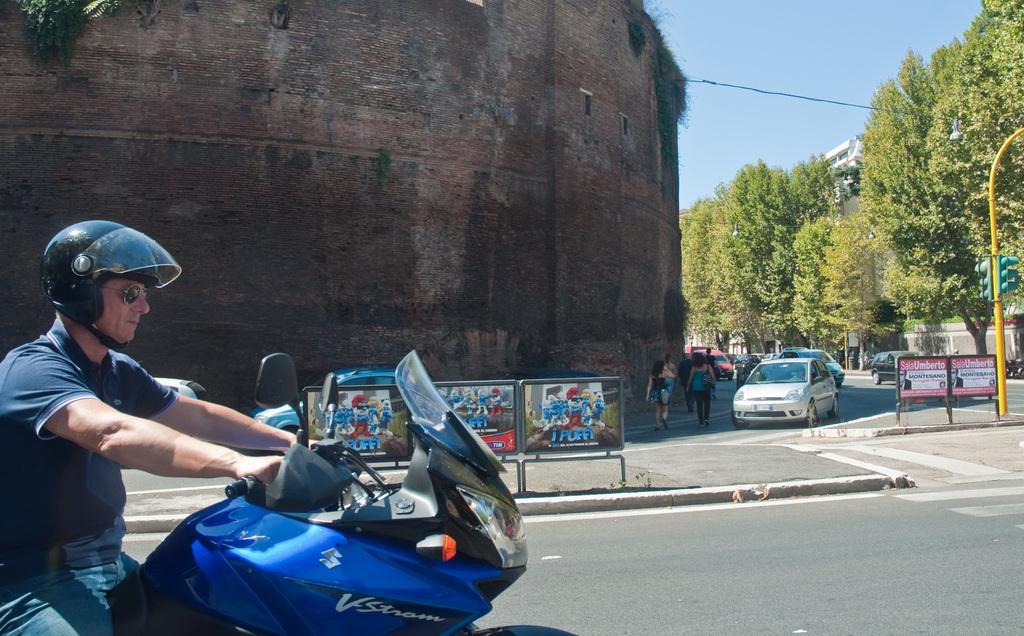How would you summarize this image in a sentence or two? This picture shows a man driving a motorcycle and he wore sunglasses on his face and helmet on his head and we see few cars moving and people walking on the side and we see a building and trees on the other side of the road traffic signal pole 